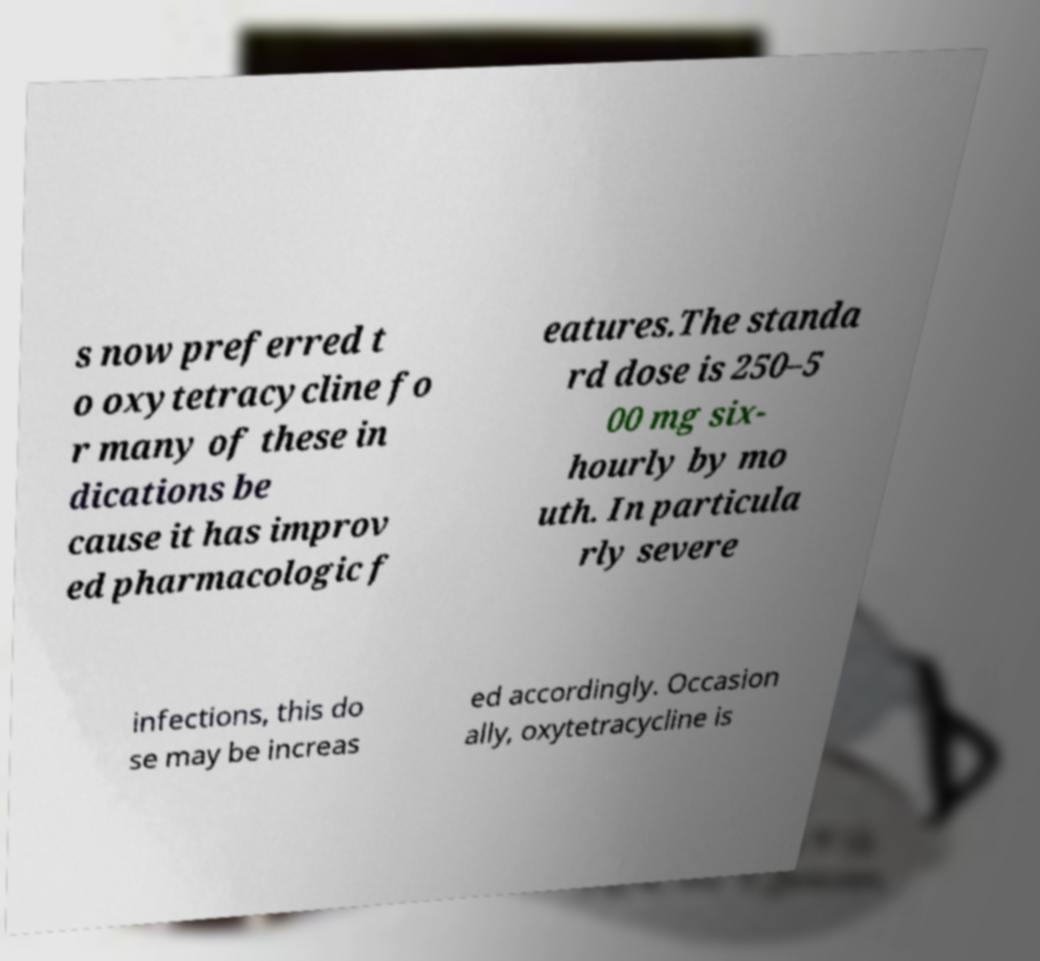Could you assist in decoding the text presented in this image and type it out clearly? s now preferred t o oxytetracycline fo r many of these in dications be cause it has improv ed pharmacologic f eatures.The standa rd dose is 250–5 00 mg six- hourly by mo uth. In particula rly severe infections, this do se may be increas ed accordingly. Occasion ally, oxytetracycline is 